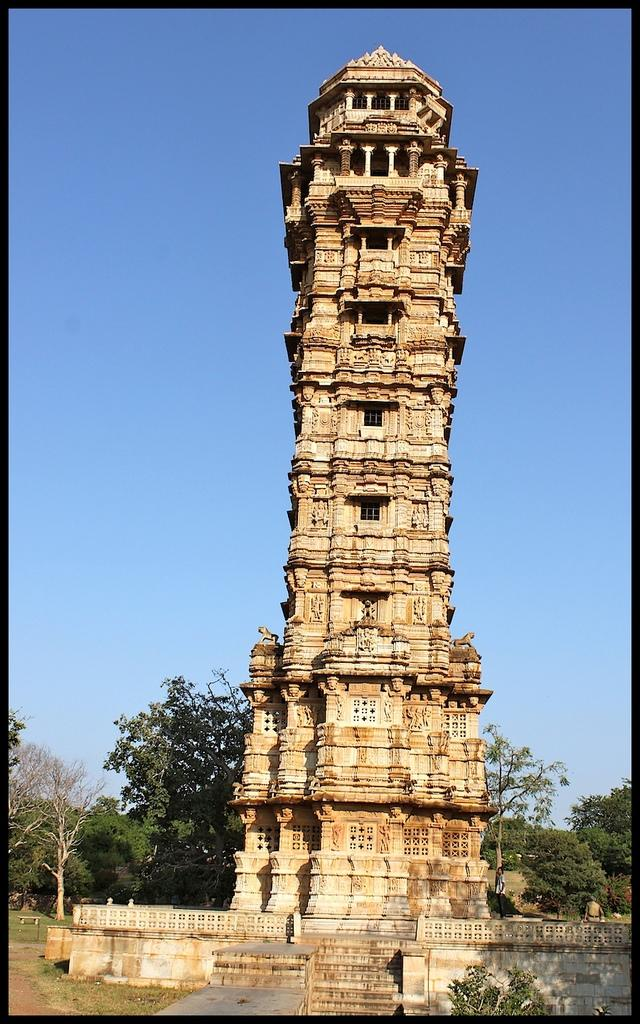What type of image is being shown? The image is an edited image. What is the main subject in the center of the image? There is a building in the center of the image. What type of vegetation can be seen in the image? There is green grass, trees, and plants visible in the image. What part of the natural environment is visible in the image? The sky is visible in the image. What type of coil is being used to clean the building in the image? There is no coil present in the image, nor is there any indication of cleaning activities taking place. What brand of toothpaste is being advertised by the building in the image? There is no toothpaste or advertisement present in the image; it simply features a building. 